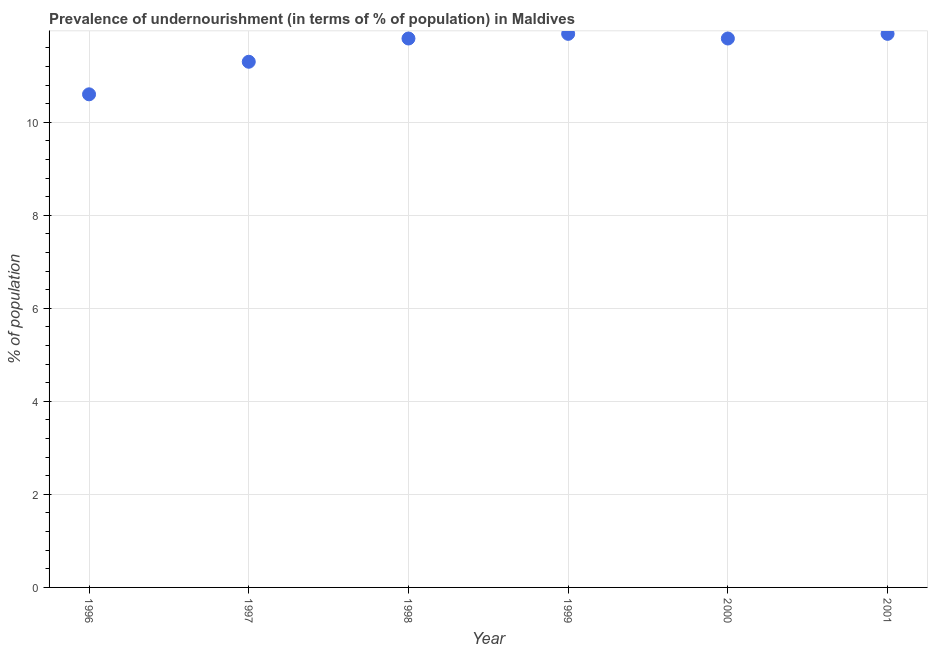Across all years, what is the maximum percentage of undernourished population?
Your answer should be compact. 11.9. In which year was the percentage of undernourished population maximum?
Your answer should be compact. 1999. In which year was the percentage of undernourished population minimum?
Offer a terse response. 1996. What is the sum of the percentage of undernourished population?
Make the answer very short. 69.3. What is the difference between the percentage of undernourished population in 1997 and 2001?
Provide a short and direct response. -0.6. What is the average percentage of undernourished population per year?
Offer a very short reply. 11.55. In how many years, is the percentage of undernourished population greater than 8.4 %?
Give a very brief answer. 6. Do a majority of the years between 1999 and 2001 (inclusive) have percentage of undernourished population greater than 3.2 %?
Provide a succinct answer. Yes. What is the ratio of the percentage of undernourished population in 1997 to that in 1999?
Make the answer very short. 0.95. Is the percentage of undernourished population in 2000 less than that in 2001?
Your answer should be very brief. Yes. Is the difference between the percentage of undernourished population in 1997 and 2001 greater than the difference between any two years?
Keep it short and to the point. No. Is the sum of the percentage of undernourished population in 1997 and 2001 greater than the maximum percentage of undernourished population across all years?
Provide a succinct answer. Yes. What is the difference between the highest and the lowest percentage of undernourished population?
Your response must be concise. 1.3. Does the percentage of undernourished population monotonically increase over the years?
Your response must be concise. No. What is the difference between two consecutive major ticks on the Y-axis?
Make the answer very short. 2. Does the graph contain any zero values?
Provide a succinct answer. No. What is the title of the graph?
Your answer should be compact. Prevalence of undernourishment (in terms of % of population) in Maldives. What is the label or title of the Y-axis?
Offer a very short reply. % of population. What is the % of population in 1996?
Provide a short and direct response. 10.6. What is the % of population in 1998?
Your answer should be very brief. 11.8. What is the % of population in 2000?
Make the answer very short. 11.8. What is the difference between the % of population in 1996 and 1997?
Your answer should be very brief. -0.7. What is the difference between the % of population in 1996 and 1998?
Keep it short and to the point. -1.2. What is the difference between the % of population in 1996 and 1999?
Provide a succinct answer. -1.3. What is the difference between the % of population in 1996 and 2001?
Your answer should be very brief. -1.3. What is the difference between the % of population in 1997 and 1998?
Provide a succinct answer. -0.5. What is the difference between the % of population in 1997 and 2001?
Your response must be concise. -0.6. What is the difference between the % of population in 1998 and 1999?
Provide a succinct answer. -0.1. What is the difference between the % of population in 1998 and 2000?
Your answer should be very brief. 0. What is the difference between the % of population in 1998 and 2001?
Provide a succinct answer. -0.1. What is the difference between the % of population in 1999 and 2000?
Provide a succinct answer. 0.1. What is the difference between the % of population in 1999 and 2001?
Your response must be concise. 0. What is the difference between the % of population in 2000 and 2001?
Your response must be concise. -0.1. What is the ratio of the % of population in 1996 to that in 1997?
Give a very brief answer. 0.94. What is the ratio of the % of population in 1996 to that in 1998?
Offer a terse response. 0.9. What is the ratio of the % of population in 1996 to that in 1999?
Offer a very short reply. 0.89. What is the ratio of the % of population in 1996 to that in 2000?
Your answer should be compact. 0.9. What is the ratio of the % of population in 1996 to that in 2001?
Your answer should be compact. 0.89. What is the ratio of the % of population in 1997 to that in 1998?
Keep it short and to the point. 0.96. What is the ratio of the % of population in 1997 to that in 2000?
Your answer should be very brief. 0.96. 